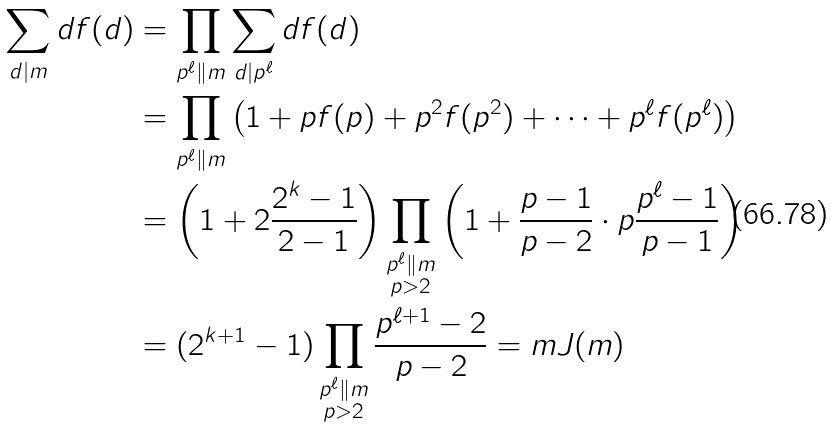Convert formula to latex. <formula><loc_0><loc_0><loc_500><loc_500>\sum _ { d | m } d f ( d ) & = \prod _ { p ^ { \ell } \| m } \sum _ { d | p ^ { \ell } } d f ( d ) \\ & = \prod _ { p ^ { \ell } \| m } \left ( 1 + p f ( p ) + p ^ { 2 } f ( p ^ { 2 } ) + \cdots + p ^ { \ell } f ( p ^ { \ell } ) \right ) \\ & = \left ( 1 + 2 \frac { 2 ^ { k } - 1 } { 2 - 1 } \right ) \prod _ { \substack { p ^ { \ell } \| m \\ p > 2 } } \left ( 1 + \frac { p - 1 } { p - 2 } \cdot p \frac { p ^ { \ell } - 1 } { p - 1 } \right ) \\ & = ( 2 ^ { k + 1 } - 1 ) \prod _ { \substack { p ^ { \ell } \| m \\ p > 2 } } \frac { p ^ { \ell + 1 } - 2 } { p - 2 } = m J ( m )</formula> 